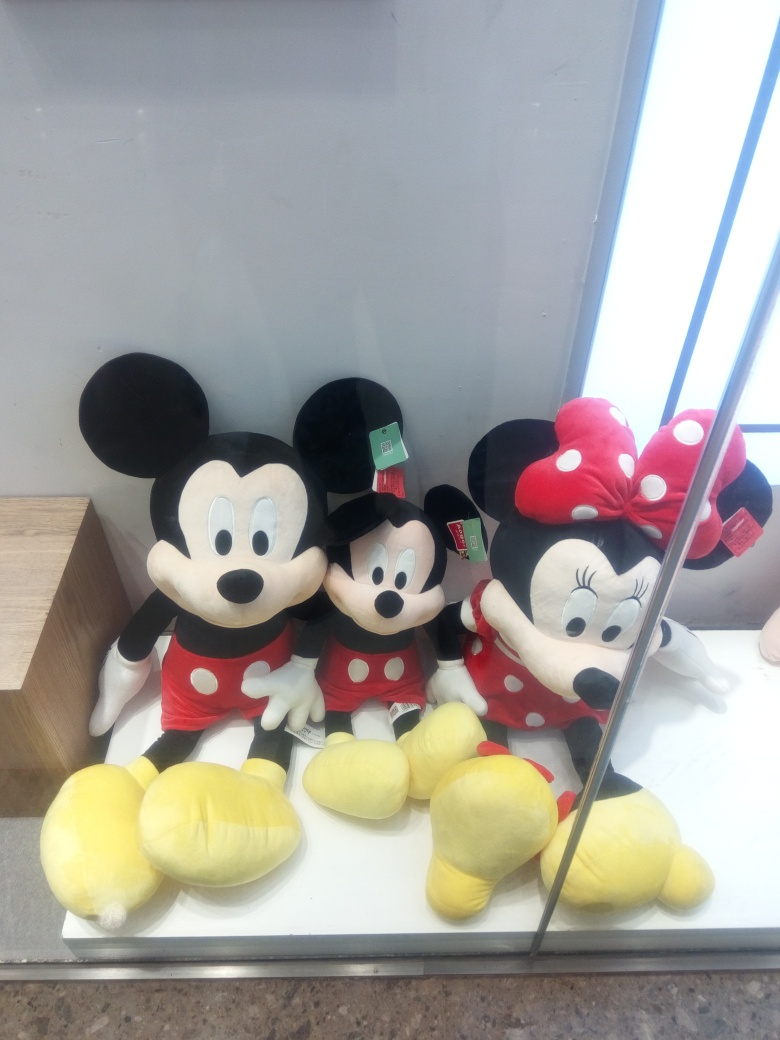Can you tell me more about the characters in the image? Sure! The image features plush toys of popular Disney characters, Mickey and Minnie Mouse. Mickey Mouse is known for his cheerful personality, trademark red shorts, and yellow shoes. Minnie Mouse typically wears a polka-dotted dress with a matching bow. They are iconic figures in animation and represent a significant part of childhood for many. Why do you think they might be displayed like this? Plush toys like these are often displayed in a visible area to attract the attention of potential buyers, especially fans of Disney characters or collectors. The arrangement in the display window is neat, making the toys appear approachable and enticing to people of all ages who may have a fondness for such iconic characters. 